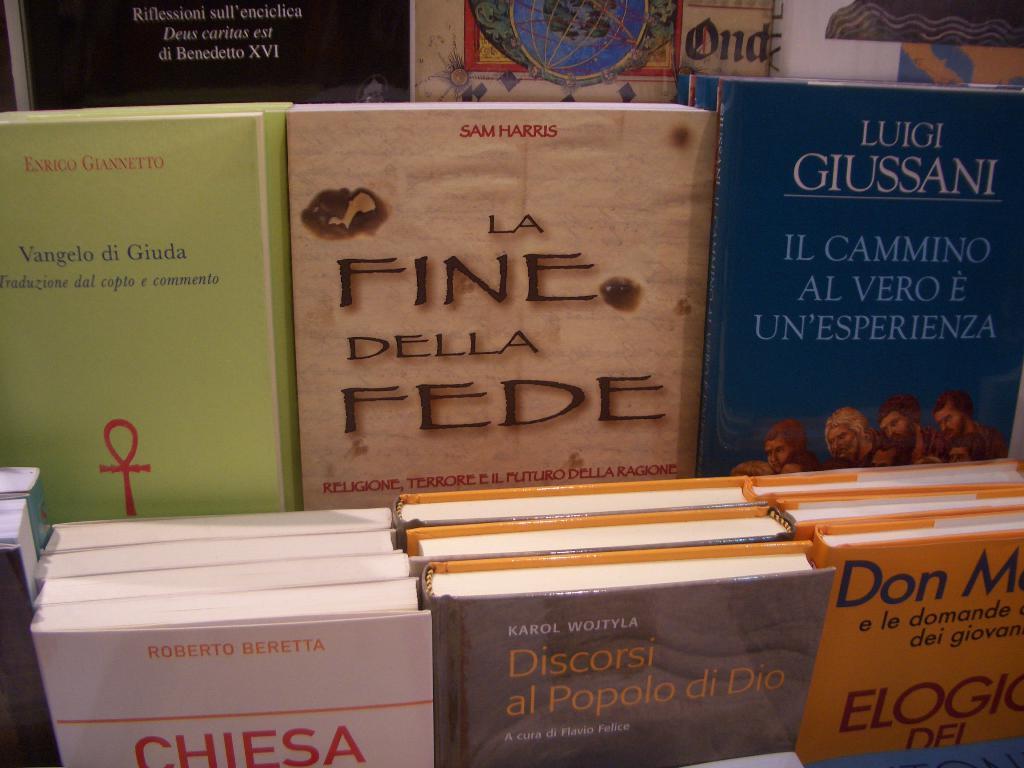Luka giussani author?
Provide a succinct answer. Yes. 